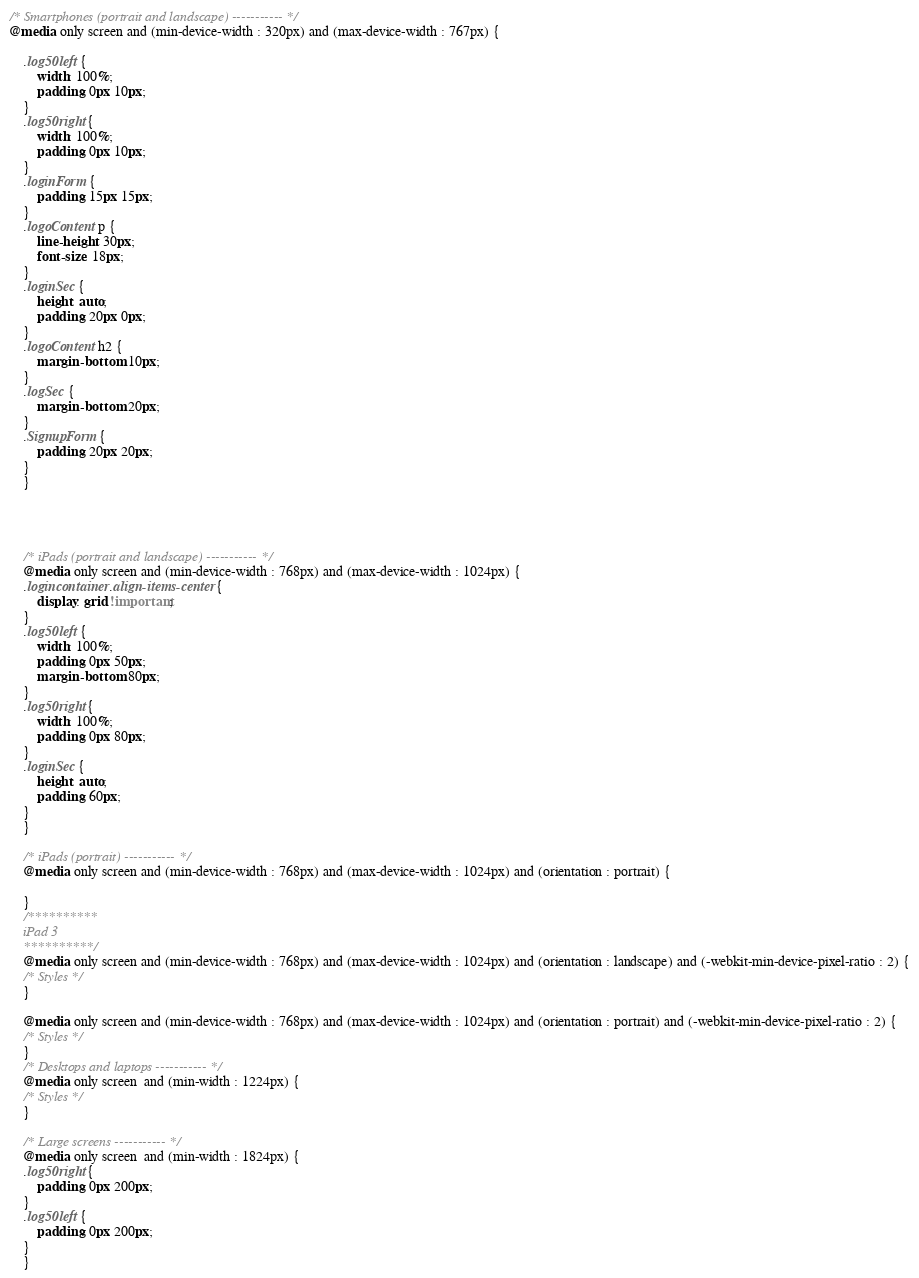Convert code to text. <code><loc_0><loc_0><loc_500><loc_500><_CSS_>/* Smartphones (portrait and landscape) ----------- */
@media only screen and (min-device-width : 320px) and (max-device-width : 767px) {

    .log50left {
        width: 100%;
        padding: 0px 10px;
    }
    .log50right {
        width: 100%;
        padding: 0px 10px;
    }
    .loginForm {
        padding: 15px 15px;
    }
    .logoContent p {
        line-height: 30px;
        font-size: 18px;
    }
    .loginSec {
        height: auto;
        padding: 20px 0px;
    }
    .logoContent h2 {
        margin-bottom: 10px;
    }
    .logSec {
        margin-bottom: 20px;
    }
    .SignupForm {
        padding: 20px 20px;
    }
    }
    
    
    
    
    /* iPads (portrait and landscape) ----------- */
    @media only screen and (min-device-width : 768px) and (max-device-width : 1024px) {
    .logincontainer .align-items-center {
        display: grid !important;
    }
    .log50left {
        width: 100%;
        padding: 0px 50px;
        margin-bottom: 80px;
    }
    .log50right {
        width: 100%;
        padding: 0px 80px;
    }
    .loginSec {
        height: auto;
        padding: 60px;
    }
    }
    
    /* iPads (portrait) ----------- */
    @media only screen and (min-device-width : 768px) and (max-device-width : 1024px) and (orientation : portrait) {
    
    }
    /**********
    iPad 3
    **********/
    @media only screen and (min-device-width : 768px) and (max-device-width : 1024px) and (orientation : landscape) and (-webkit-min-device-pixel-ratio : 2) {
    /* Styles */
    }
    
    @media only screen and (min-device-width : 768px) and (max-device-width : 1024px) and (orientation : portrait) and (-webkit-min-device-pixel-ratio : 2) {
    /* Styles */
    }
    /* Desktops and laptops ----------- */
    @media only screen  and (min-width : 1224px) {
    /* Styles */
    }
    
    /* Large screens ----------- */
    @media only screen  and (min-width : 1824px) {
    .log50right {
        padding: 0px 200px;
    }
    .log50left {
        padding: 0px 200px;
    }
    }</code> 